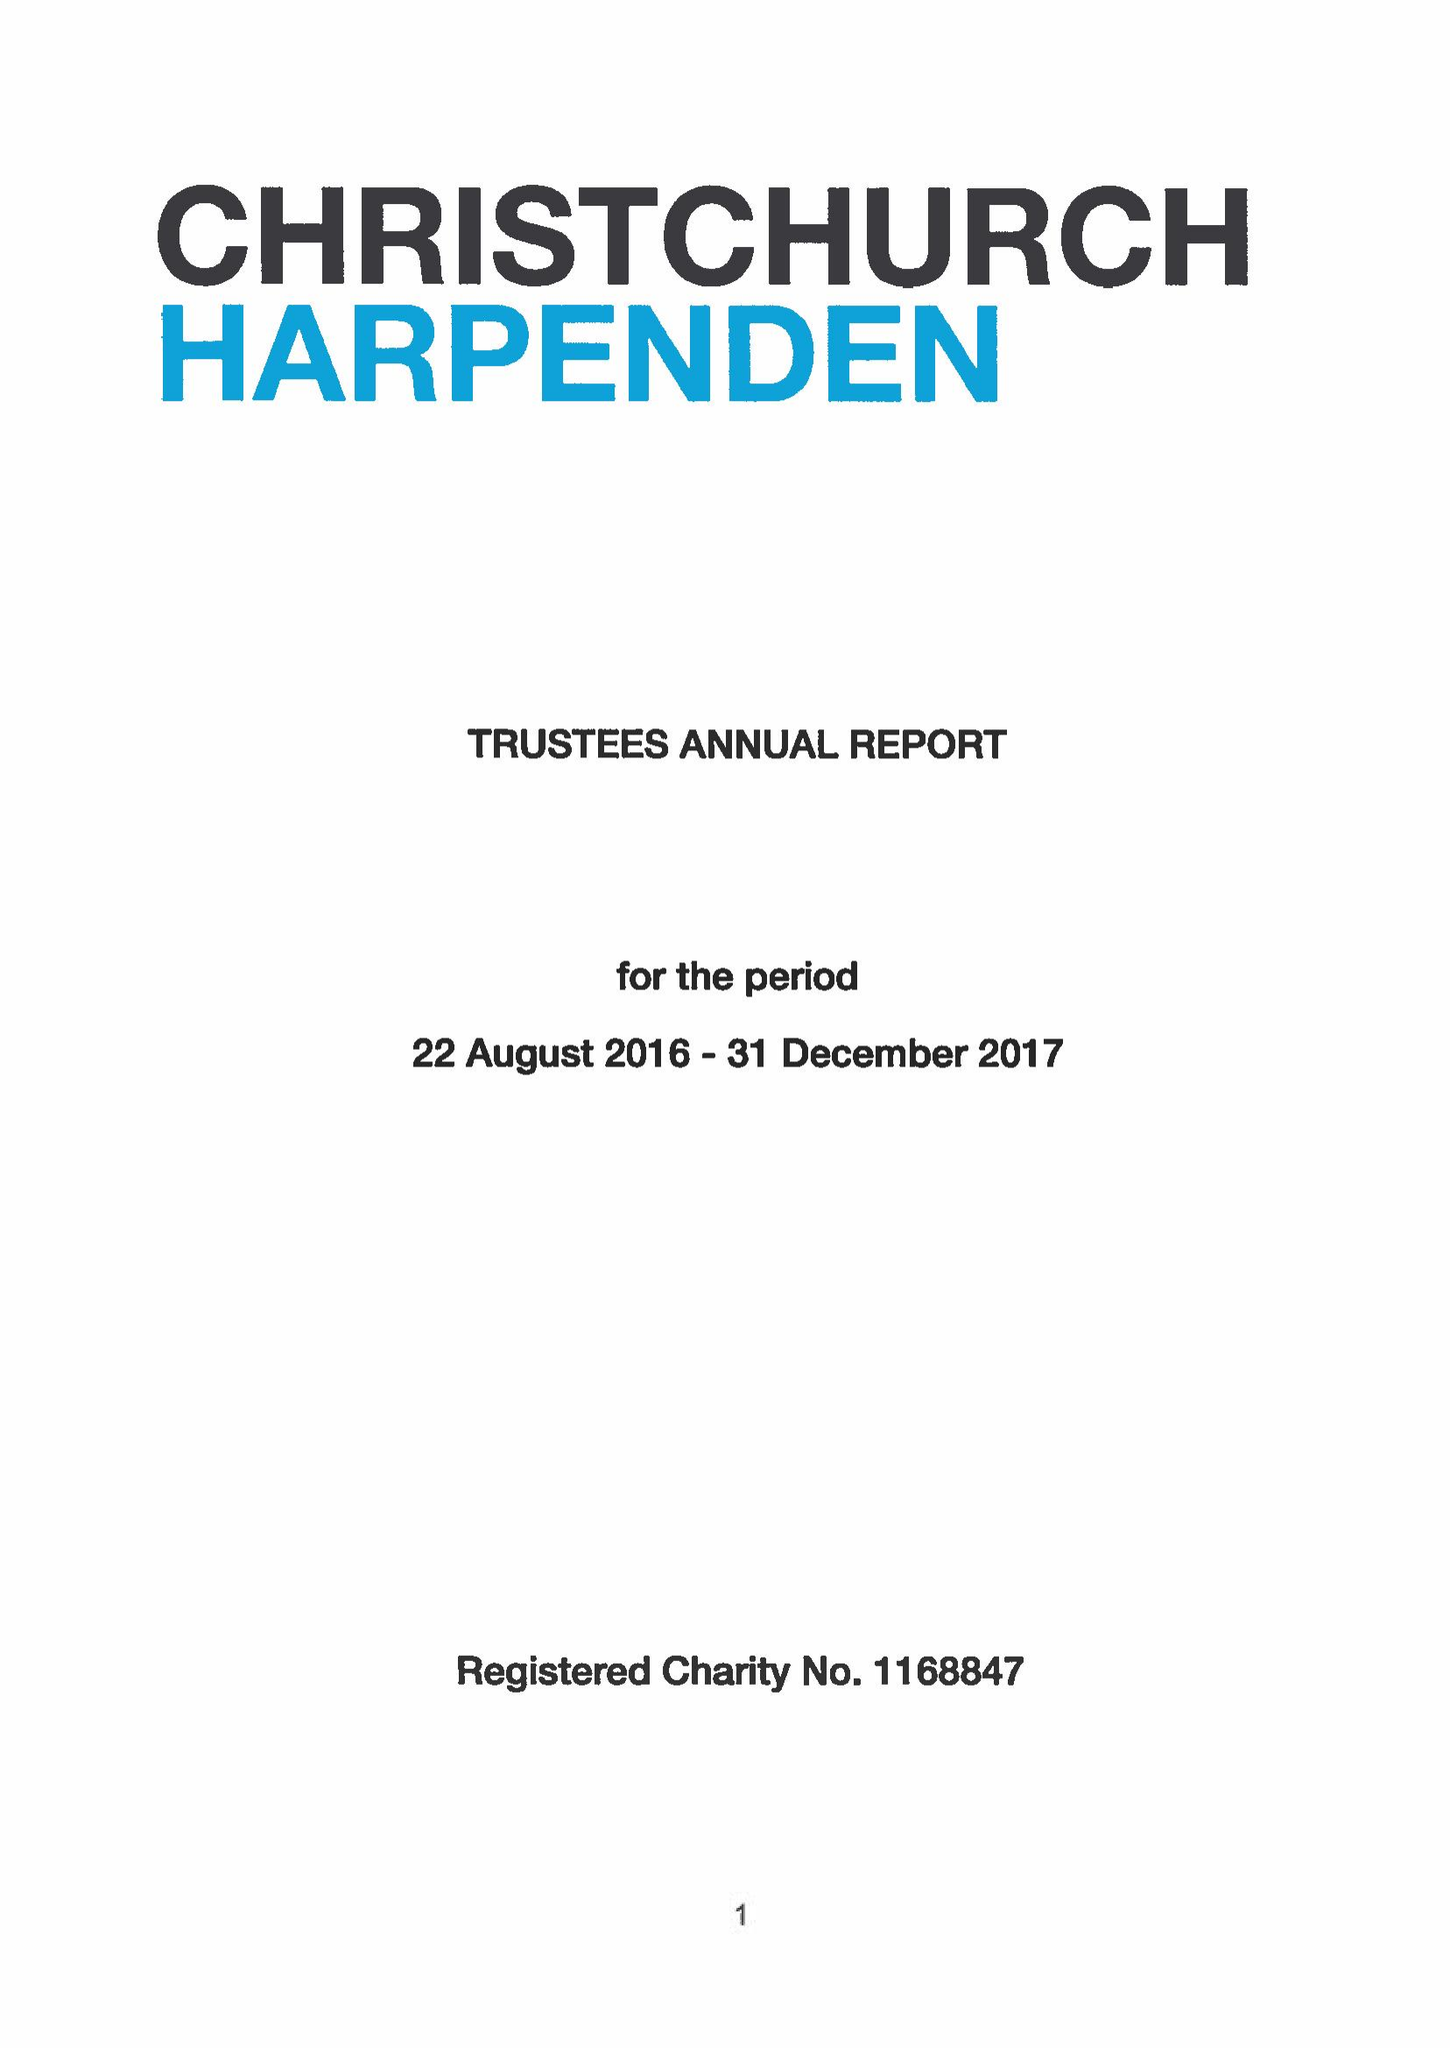What is the value for the address__postcode?
Answer the question using a single word or phrase. AL5 4ED 